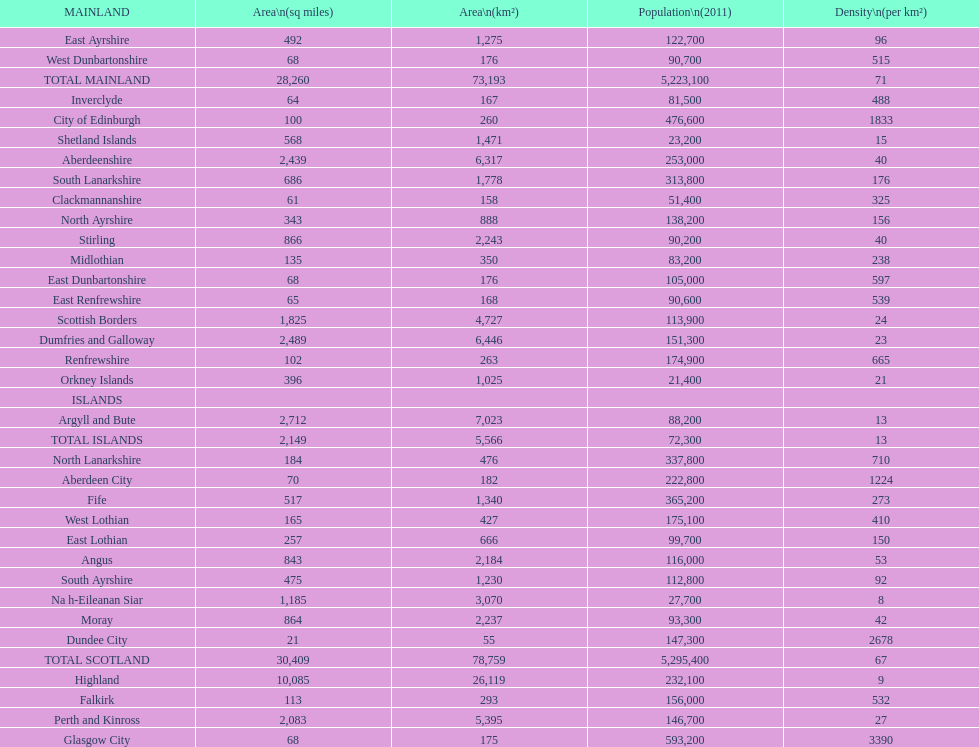I'm looking to parse the entire table for insights. Could you assist me with that? {'header': ['MAINLAND', 'Area\\n(sq miles)', 'Area\\n(km²)', 'Population\\n(2011)', 'Density\\n(per km²)'], 'rows': [['East Ayrshire', '492', '1,275', '122,700', '96'], ['West Dunbartonshire', '68', '176', '90,700', '515'], ['TOTAL MAINLAND', '28,260', '73,193', '5,223,100', '71'], ['Inverclyde', '64', '167', '81,500', '488'], ['City of Edinburgh', '100', '260', '476,600', '1833'], ['Shetland Islands', '568', '1,471', '23,200', '15'], ['Aberdeenshire', '2,439', '6,317', '253,000', '40'], ['South Lanarkshire', '686', '1,778', '313,800', '176'], ['Clackmannanshire', '61', '158', '51,400', '325'], ['North Ayrshire', '343', '888', '138,200', '156'], ['Stirling', '866', '2,243', '90,200', '40'], ['Midlothian', '135', '350', '83,200', '238'], ['East Dunbartonshire', '68', '176', '105,000', '597'], ['East Renfrewshire', '65', '168', '90,600', '539'], ['Scottish Borders', '1,825', '4,727', '113,900', '24'], ['Dumfries and Galloway', '2,489', '6,446', '151,300', '23'], ['Renfrewshire', '102', '263', '174,900', '665'], ['Orkney Islands', '396', '1,025', '21,400', '21'], ['ISLANDS', '', '', '', ''], ['Argyll and Bute', '2,712', '7,023', '88,200', '13'], ['TOTAL ISLANDS', '2,149', '5,566', '72,300', '13'], ['North Lanarkshire', '184', '476', '337,800', '710'], ['Aberdeen City', '70', '182', '222,800', '1224'], ['Fife', '517', '1,340', '365,200', '273'], ['West Lothian', '165', '427', '175,100', '410'], ['East Lothian', '257', '666', '99,700', '150'], ['Angus', '843', '2,184', '116,000', '53'], ['South Ayrshire', '475', '1,230', '112,800', '92'], ['Na h-Eileanan Siar', '1,185', '3,070', '27,700', '8'], ['Moray', '864', '2,237', '93,300', '42'], ['Dundee City', '21', '55', '147,300', '2678'], ['TOTAL SCOTLAND', '30,409', '78,759', '5,295,400', '67'], ['Highland', '10,085', '26,119', '232,100', '9'], ['Falkirk', '113', '293', '156,000', '532'], ['Perth and Kinross', '2,083', '5,395', '146,700', '27'], ['Glasgow City', '68', '175', '593,200', '3390']]} What is the number of people living in angus in 2011? 116,000. 